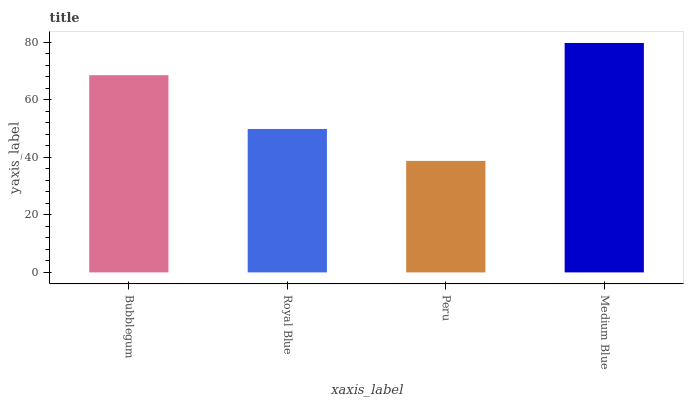Is Royal Blue the minimum?
Answer yes or no. No. Is Royal Blue the maximum?
Answer yes or no. No. Is Bubblegum greater than Royal Blue?
Answer yes or no. Yes. Is Royal Blue less than Bubblegum?
Answer yes or no. Yes. Is Royal Blue greater than Bubblegum?
Answer yes or no. No. Is Bubblegum less than Royal Blue?
Answer yes or no. No. Is Bubblegum the high median?
Answer yes or no. Yes. Is Royal Blue the low median?
Answer yes or no. Yes. Is Medium Blue the high median?
Answer yes or no. No. Is Medium Blue the low median?
Answer yes or no. No. 